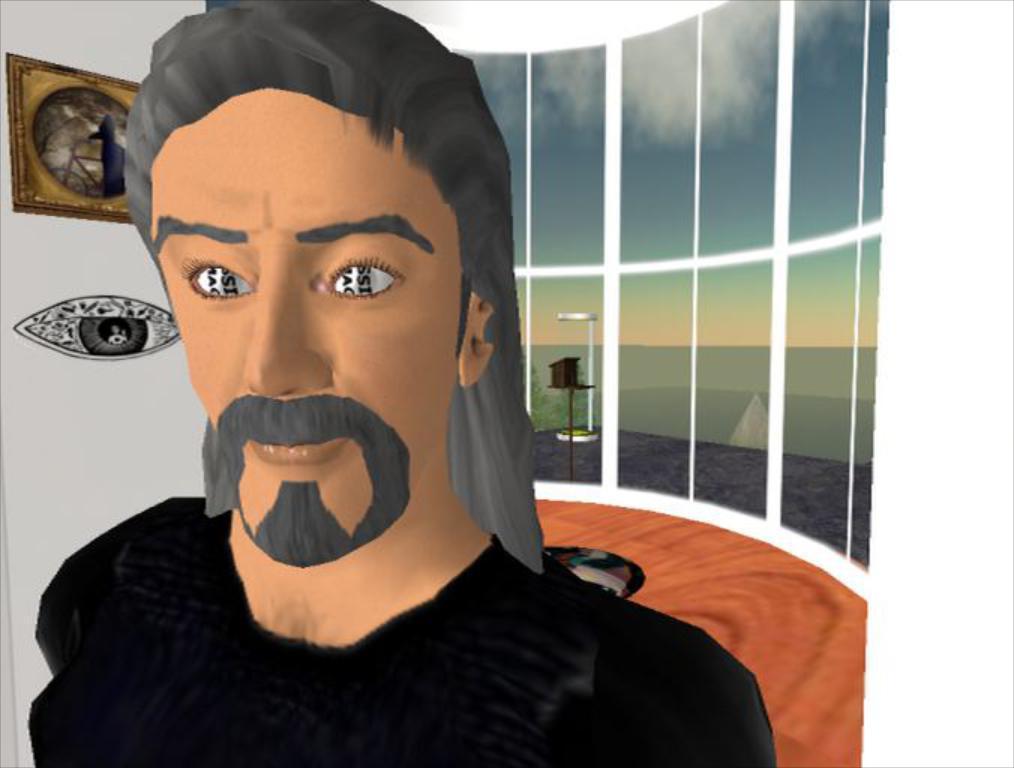Describe this image in one or two sentences. In this picture we can observe a graphic. There is a person wearing black color dress. We can observe glass windows behind him. There is a photo frame fixed to the wall on the left side. In the background there is a sky with some clouds. 